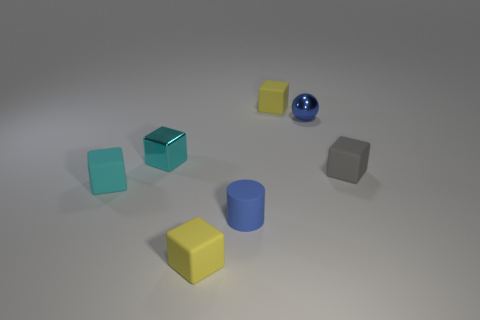Do the small gray matte object that is right of the blue matte cylinder and the tiny yellow object left of the tiny blue matte cylinder have the same shape?
Give a very brief answer. Yes. What is the color of the tiny cylinder behind the rubber block that is in front of the small blue object that is in front of the blue metallic thing?
Offer a very short reply. Blue. How many other things are the same color as the cylinder?
Provide a short and direct response. 1. Is the number of small gray objects less than the number of things?
Offer a terse response. Yes. The tiny rubber object that is right of the blue cylinder and to the left of the gray matte thing is what color?
Make the answer very short. Yellow. What material is the other tiny cyan thing that is the same shape as the small cyan metal object?
Ensure brevity in your answer.  Rubber. Are there any other things that are the same size as the shiny sphere?
Your response must be concise. Yes. Are there more cyan cubes than green metallic cylinders?
Your response must be concise. Yes. What is the size of the rubber cube that is behind the matte cylinder and in front of the gray cube?
Your answer should be compact. Small. There is a tiny cyan matte thing; what shape is it?
Ensure brevity in your answer.  Cube. 